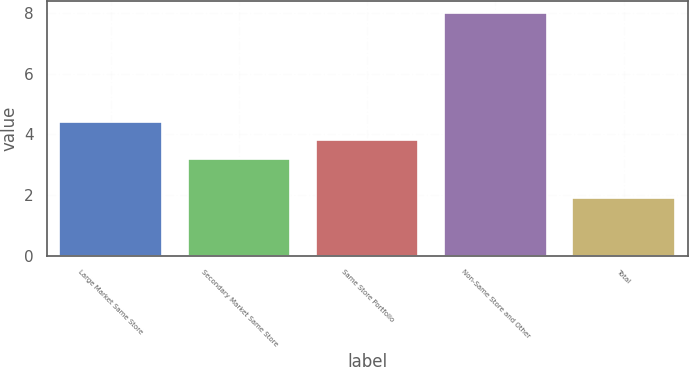Convert chart. <chart><loc_0><loc_0><loc_500><loc_500><bar_chart><fcel>Large Market Same Store<fcel>Secondary Market Same Store<fcel>Same Store Portfolio<fcel>Non-Same Store and Other<fcel>Total<nl><fcel>4.42<fcel>3.2<fcel>3.81<fcel>8<fcel>1.9<nl></chart> 